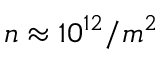<formula> <loc_0><loc_0><loc_500><loc_500>n \approx 1 0 ^ { 1 2 } / m ^ { 2 }</formula> 